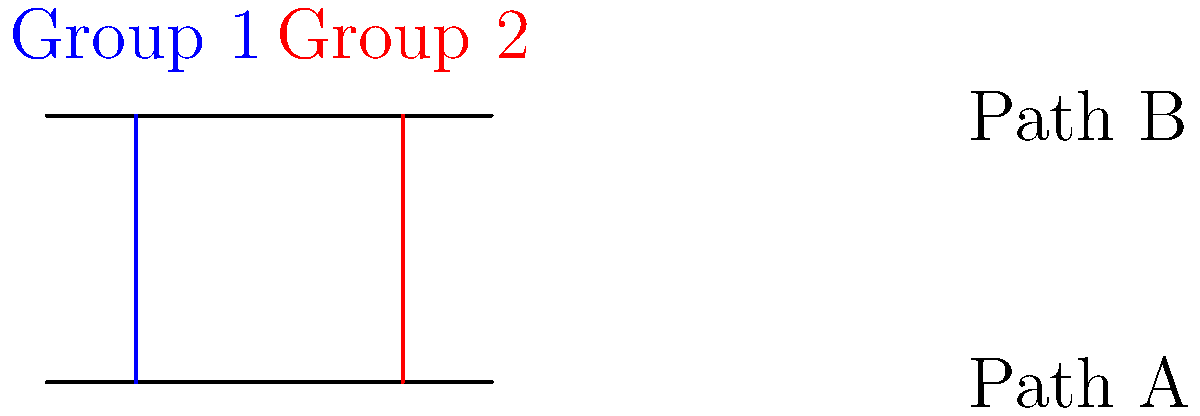In the diagram, two parallel lines represent immigration paths A and B. The blue line represents the journey of immigrant Group 1, and the red line represents Group 2. If the angle formed by Group 1's path with Path A is $x°$, and the angle formed by Group 2's path with Path B is $y°$, what is the relationship between $x$ and $y$? Explain your reasoning using the properties of parallel lines and transversals. To solve this problem, we need to apply the properties of parallel lines and transversals:

1. Path A and Path B are parallel lines.
2. The blue line (Group 1) and red line (Group 2) act as transversals.
3. When a transversal crosses parallel lines, corresponding angles are congruent.

Step 1: Identify the angles
- $x°$ is the angle formed by Group 1's path with Path A
- $y°$ is the angle formed by Group 2's path with Path B

Step 2: Recognize corresponding angles
- The angle $x°$ corresponds to the angle formed by Group 1's path with Path B (top left)
- The angle $y°$ corresponds to the angle formed by Group 2's path with Path A (bottom right)

Step 3: Apply the corresponding angles theorem
- Since corresponding angles are congruent when a transversal crosses parallel lines, we can conclude that:
  - The angle formed by Group 1's path with Path B (top left) is also $x°$
  - The angle formed by Group 2's path with Path A (bottom right) is also $y°$

Step 4: Analyze the relationship
- The two transversals (Group 1 and Group 2 paths) form a pair of alternate interior angles between the parallel lines
- Alternate interior angles are congruent when formed by a transversal crossing parallel lines

Therefore, we can conclude that $x° = y°$. The angles formed by both immigrant groups' paths with their respective immigration paths are equal.
Answer: $x° = y°$ 